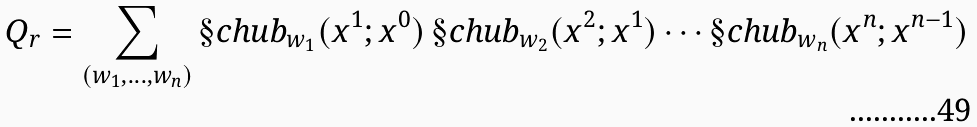<formula> <loc_0><loc_0><loc_500><loc_500>Q _ { r } = \sum _ { ( w _ { 1 } , \dots , w _ { n } ) } \S c h u b _ { w _ { 1 } } ( x ^ { 1 } ; x ^ { 0 } ) \, \S c h u b _ { w _ { 2 } } ( x ^ { 2 } ; x ^ { 1 } ) \cdots \S c h u b _ { w _ { n } } ( x ^ { n } ; x ^ { n - 1 } )</formula> 